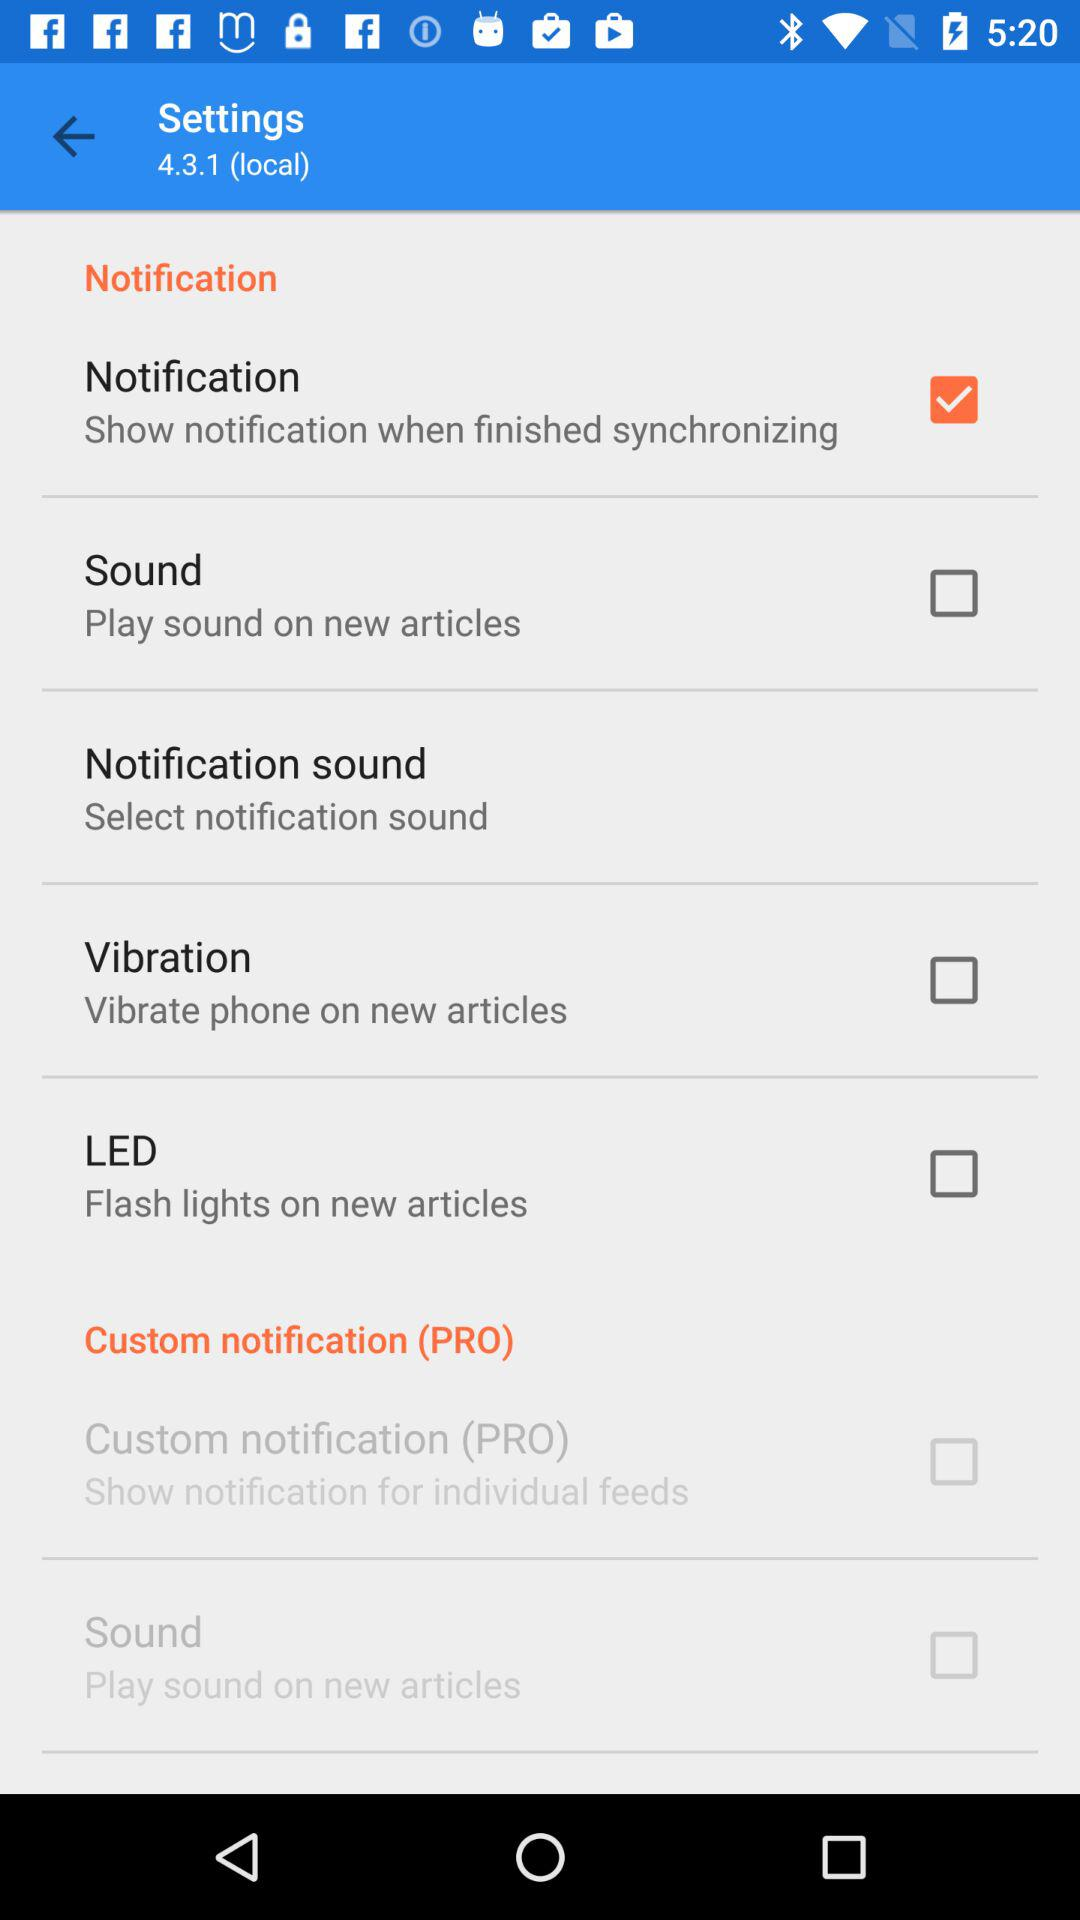What is the status of Sound? The status is "off". 